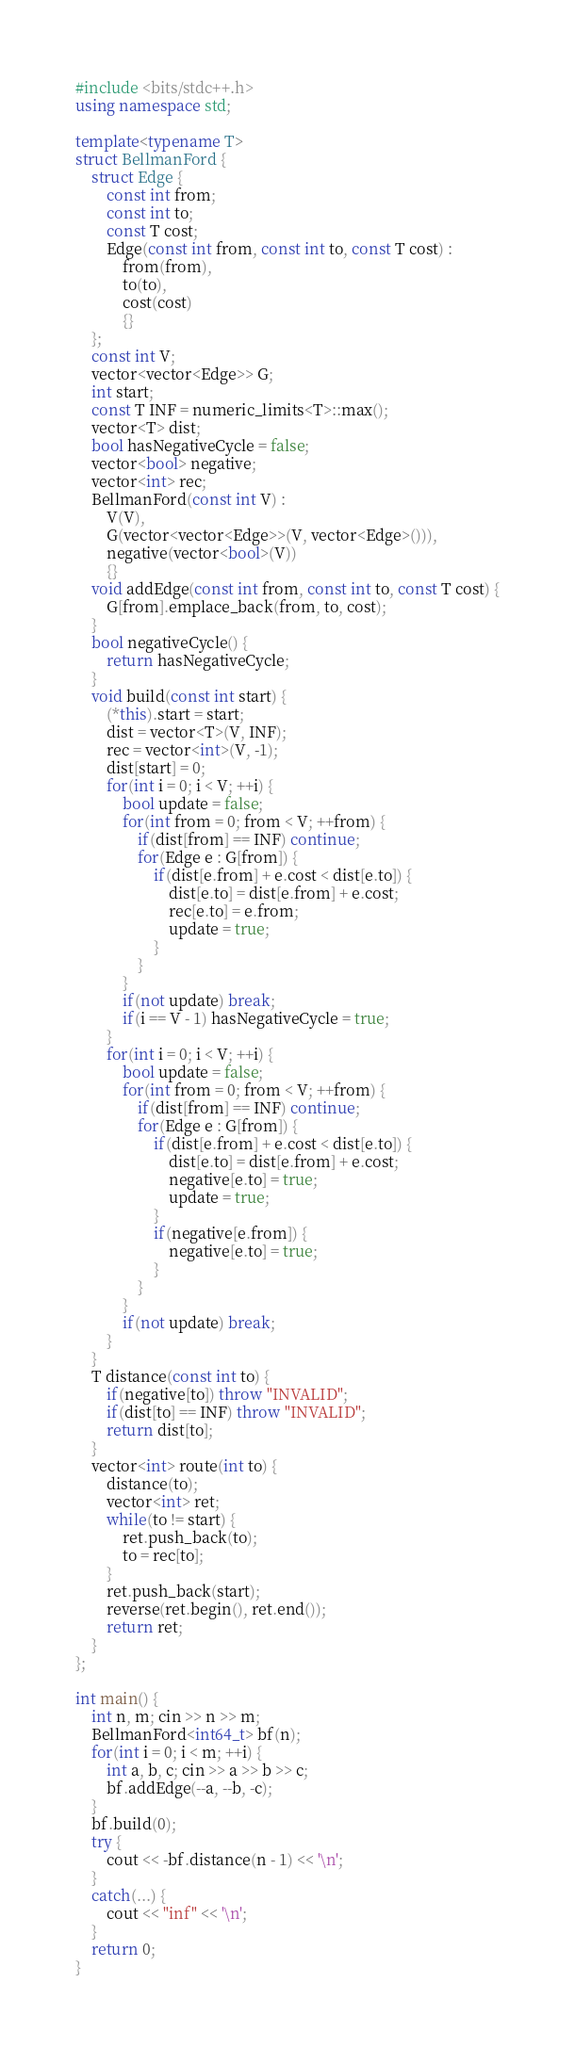Convert code to text. <code><loc_0><loc_0><loc_500><loc_500><_C++_>#include <bits/stdc++.h>
using namespace std;

template<typename T>
struct BellmanFord {
	struct Edge {
		const int from;
		const int to;
		const T cost;
		Edge(const int from, const int to, const T cost) :
			from(from),
			to(to),
			cost(cost)
			{}
	};
	const int V;
	vector<vector<Edge>> G;
	int start;
	const T INF = numeric_limits<T>::max();
	vector<T> dist;
	bool hasNegativeCycle = false;
	vector<bool> negative;
	vector<int> rec;
	BellmanFord(const int V) :
		V(V),
		G(vector<vector<Edge>>(V, vector<Edge>())),
		negative(vector<bool>(V))
		{}
	void addEdge(const int from, const int to, const T cost) {
		G[from].emplace_back(from, to, cost);
	}
	bool negativeCycle() {
		return hasNegativeCycle;
	}
	void build(const int start) {
		(*this).start = start;
		dist = vector<T>(V, INF);
		rec = vector<int>(V, -1);
		dist[start] = 0;
		for(int i = 0; i < V; ++i) {
			bool update = false;
			for(int from = 0; from < V; ++from) {
				if(dist[from] == INF) continue;
				for(Edge e : G[from]) {
					if(dist[e.from] + e.cost < dist[e.to]) {
						dist[e.to] = dist[e.from] + e.cost;
						rec[e.to] = e.from;
						update = true;
					}
				}
			}
			if(not update) break;
			if(i == V - 1) hasNegativeCycle = true;
		}
		for(int i = 0; i < V; ++i) {
			bool update = false;
			for(int from = 0; from < V; ++from) {
				if(dist[from] == INF) continue;
				for(Edge e : G[from]) {
					if(dist[e.from] + e.cost < dist[e.to]) {
						dist[e.to] = dist[e.from] + e.cost;
						negative[e.to] = true;
						update = true;
					}
					if(negative[e.from]) {
						negative[e.to] = true;
					}
				}
			}
			if(not update) break;
		}
	}
	T distance(const int to) {
		if(negative[to]) throw "INVALID";
		if(dist[to] == INF) throw "INVALID";
		return dist[to];
	}
	vector<int> route(int to) {
		distance(to);
		vector<int> ret;
		while(to != start) {
			ret.push_back(to);
			to = rec[to];
		}
		ret.push_back(start);
		reverse(ret.begin(), ret.end());
		return ret;
	}
};

int main() {
	int n, m; cin >> n >> m;
	BellmanFord<int64_t> bf(n);
	for(int i = 0; i < m; ++i) {
		int a, b, c; cin >> a >> b >> c;
		bf.addEdge(--a, --b, -c);
	}
	bf.build(0);
	try {
		cout << -bf.distance(n - 1) << '\n';
	}
	catch(...) {
		cout << "inf" << '\n';
	}
	return 0;
}</code> 